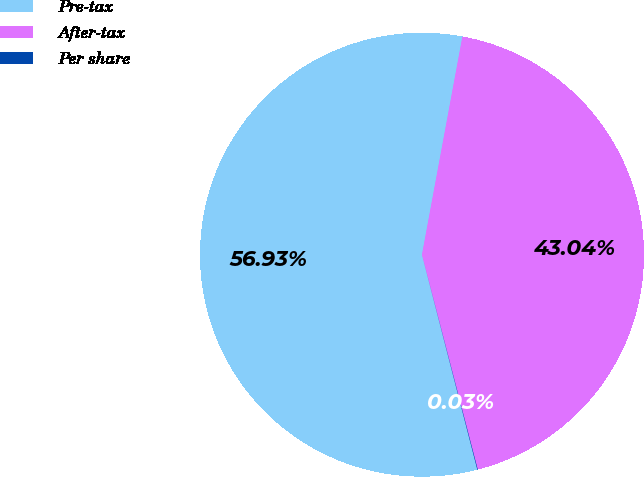<chart> <loc_0><loc_0><loc_500><loc_500><pie_chart><fcel>Pre-tax<fcel>After-tax<fcel>Per share<nl><fcel>56.93%<fcel>43.04%<fcel>0.03%<nl></chart> 